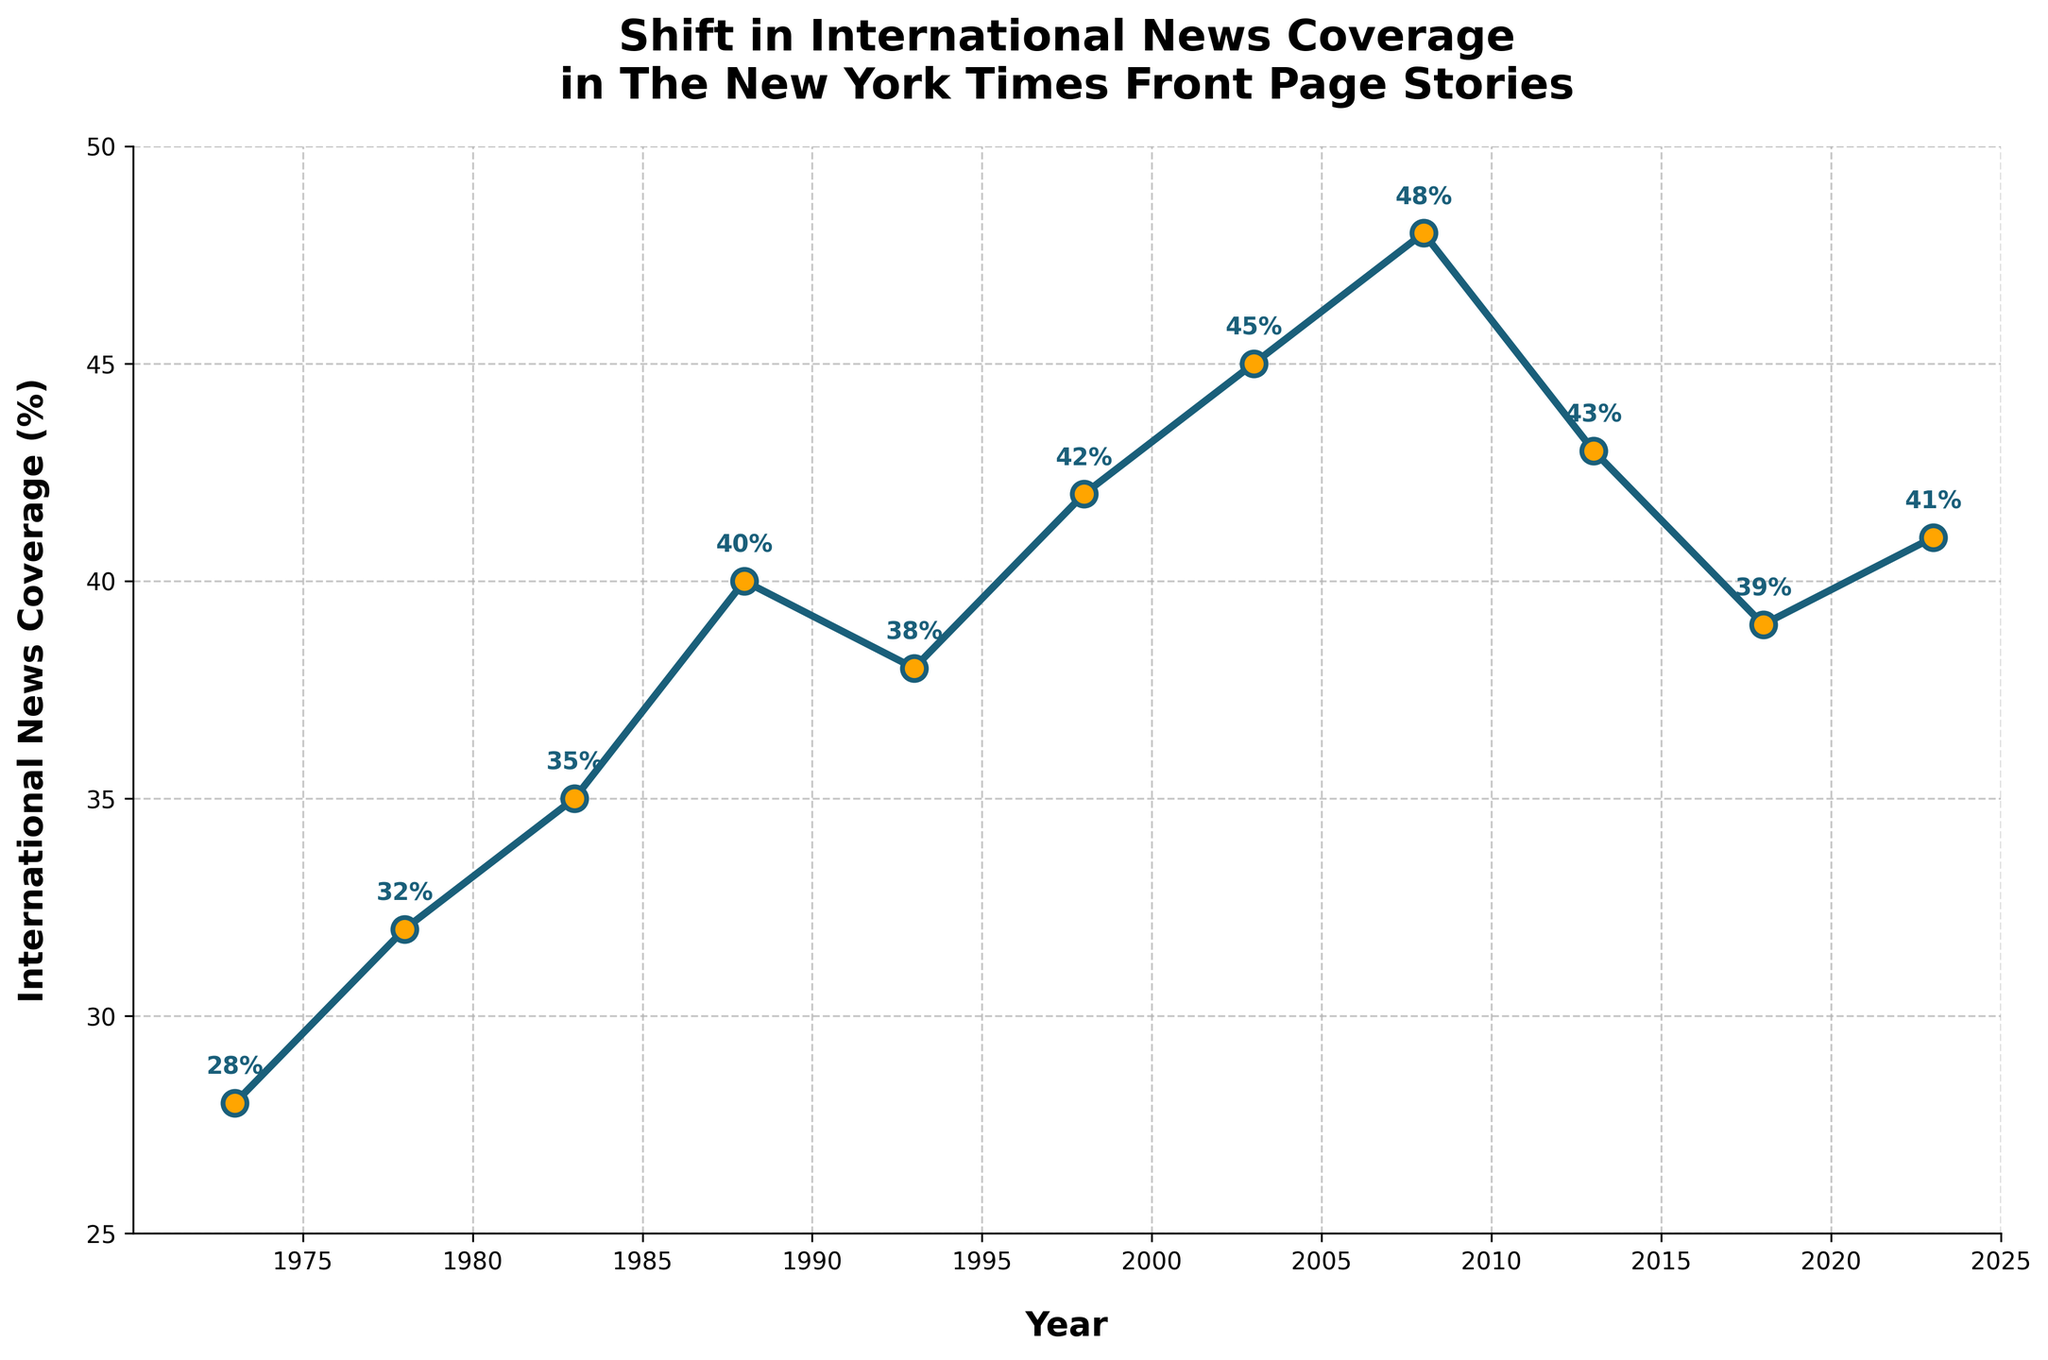What is the highest percentage of international news coverage over the last 50 years? The highest percentage of international news coverage is the peak value on the y-axis of the chart. The peak value appears to be 48% in 2008.
Answer: 48% Which year saw the lowest percentage of international news coverage? The lowest point on the y-axis represents the lowest percentage of international news coverage. The minimum value is 28% in 1973.
Answer: 1973 How much did the international news coverage increase from 1973 to 1988? Subtract the international news coverage in 1973 from the coverage in 1988. (40% - 28%) = 12%.
Answer: 12% Between which two consecutive years was there the greatest increase in international news coverage? Calculate the difference in international news coverage between each consecutive pair of years and identify the maximum increase. The greatest increase was from 2003 (45%) to 2008 (48%), which is 3%.
Answer: 2003 to 2008 What is the average percentage of international news coverage from 2003 to 2023? Sum the coverage percentages from 2003 to 2023 and divide by the number of data points: (45% + 48% + 43% + 39% + 41%) / 5 = 43.2%.
Answer: 43.2% In which year did the international news coverage drop after its peak in 2008? Locate the peak in 2008 (48%), then identify the next year's data point where it drops: 2013 (43%).
Answer: 2013 Compare the percentage changes in international news coverage between 1978 and 1983 with that between 1988 and 1993. Which one is larger? Calculate the change for each period: 1983 (35%) - 1978 (32%) = 3%, and 1993 (38%) - 1988 (40%) = -2%. The change between 1978 and 1983 is larger.
Answer: 1978 to 1983 At what rate did the international news coverage change from 2013 to 2023? The coverage changed from 43% in 2013 to 41% in 2023: (41% - 43%) / 10 years = -0.2% per year.
Answer: -0.2% per year Which year had exactly 42% coverage, and which year was closest to this value without being exactly 42%? The chart indicates that 1998 had exactly 42% coverage, while 2023 with 41% is the closest value that is not exactly 42%.
Answer: 1998 and 2023 